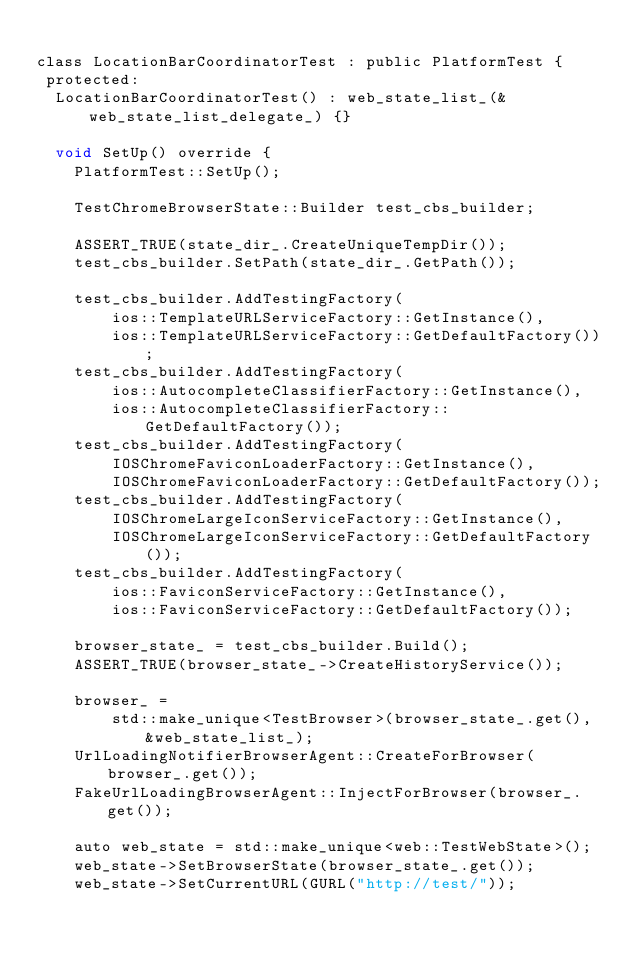<code> <loc_0><loc_0><loc_500><loc_500><_ObjectiveC_>
class LocationBarCoordinatorTest : public PlatformTest {
 protected:
  LocationBarCoordinatorTest() : web_state_list_(&web_state_list_delegate_) {}

  void SetUp() override {
    PlatformTest::SetUp();

    TestChromeBrowserState::Builder test_cbs_builder;

    ASSERT_TRUE(state_dir_.CreateUniqueTempDir());
    test_cbs_builder.SetPath(state_dir_.GetPath());

    test_cbs_builder.AddTestingFactory(
        ios::TemplateURLServiceFactory::GetInstance(),
        ios::TemplateURLServiceFactory::GetDefaultFactory());
    test_cbs_builder.AddTestingFactory(
        ios::AutocompleteClassifierFactory::GetInstance(),
        ios::AutocompleteClassifierFactory::GetDefaultFactory());
    test_cbs_builder.AddTestingFactory(
        IOSChromeFaviconLoaderFactory::GetInstance(),
        IOSChromeFaviconLoaderFactory::GetDefaultFactory());
    test_cbs_builder.AddTestingFactory(
        IOSChromeLargeIconServiceFactory::GetInstance(),
        IOSChromeLargeIconServiceFactory::GetDefaultFactory());
    test_cbs_builder.AddTestingFactory(
        ios::FaviconServiceFactory::GetInstance(),
        ios::FaviconServiceFactory::GetDefaultFactory());

    browser_state_ = test_cbs_builder.Build();
    ASSERT_TRUE(browser_state_->CreateHistoryService());

    browser_ =
        std::make_unique<TestBrowser>(browser_state_.get(), &web_state_list_);
    UrlLoadingNotifierBrowserAgent::CreateForBrowser(browser_.get());
    FakeUrlLoadingBrowserAgent::InjectForBrowser(browser_.get());

    auto web_state = std::make_unique<web::TestWebState>();
    web_state->SetBrowserState(browser_state_.get());
    web_state->SetCurrentURL(GURL("http://test/"));</code> 